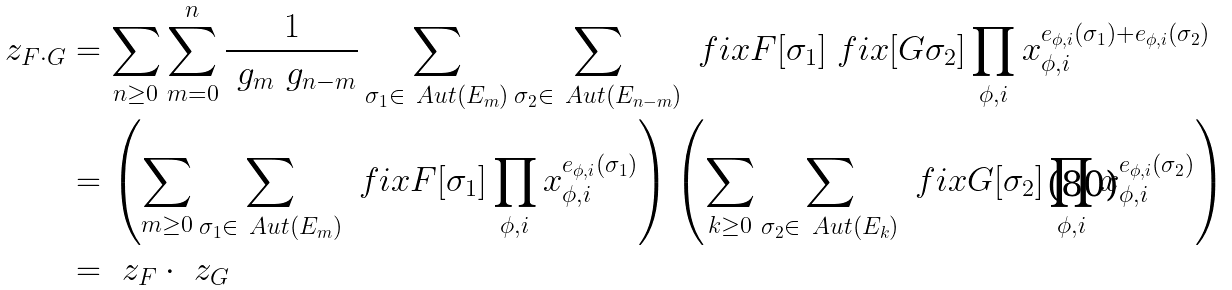Convert formula to latex. <formula><loc_0><loc_0><loc_500><loc_500>\ z _ { F \cdot G } & = \sum _ { n \geq 0 } \sum _ { m = 0 } ^ { n } \frac { 1 } { \ g _ { m } \ g _ { n - m } } \sum _ { \sigma _ { 1 } \in \ A u t ( E _ { m } ) } \sum _ { \sigma _ { 2 } \in \ A u t ( E _ { n - m } ) } \ f i x F [ \sigma _ { 1 } ] \ f i x [ G \sigma _ { 2 } ] \prod _ { \phi , i } x _ { \phi , i } ^ { e _ { \phi , i } ( \sigma _ { 1 } ) + e _ { \phi , i } ( \sigma _ { 2 } ) } \\ & = \left ( \sum _ { m \geq 0 } \sum _ { \sigma _ { 1 } \in \ A u t ( E _ { m } ) } \ f i x F [ \sigma _ { 1 } ] \prod _ { \phi , i } x _ { \phi , i } ^ { e _ { \phi , i } ( \sigma _ { 1 } ) } \right ) \left ( \sum _ { k \geq 0 } \sum _ { \sigma _ { 2 } \in \ A u t ( E _ { k } ) } \ f i x G [ \sigma _ { 2 } ] \prod _ { \phi , i } x _ { \phi , i } ^ { e _ { \phi , i } ( \sigma _ { 2 } ) } \right ) \\ & = \ z _ { F } \cdot \ z _ { G }</formula> 